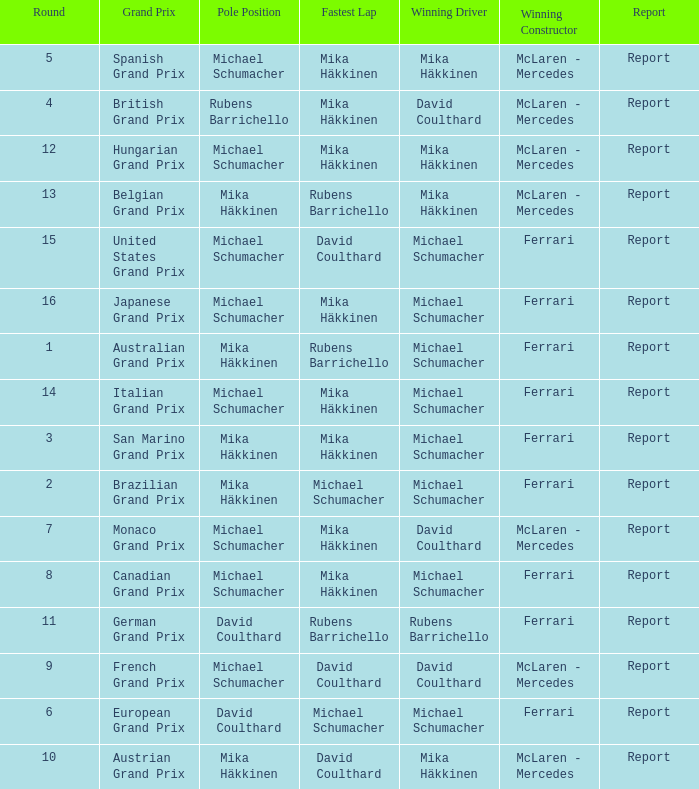What was the report of the Belgian Grand Prix? Report. 